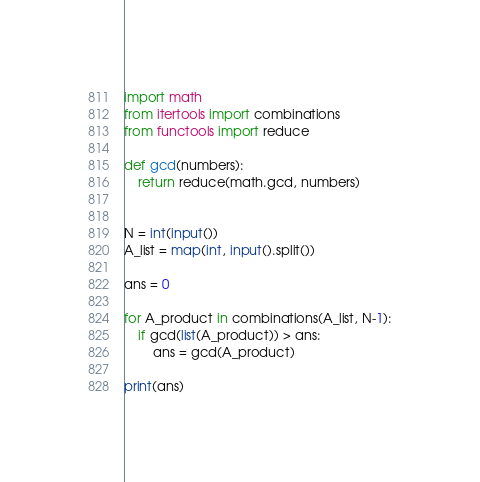<code> <loc_0><loc_0><loc_500><loc_500><_Python_>import math
from itertools import combinations
from functools import reduce

def gcd(numbers):
    return reduce(math.gcd, numbers)


N = int(input())
A_list = map(int, input().split())

ans = 0

for A_product in combinations(A_list, N-1):
    if gcd(list(A_product)) > ans:
        ans = gcd(A_product)

print(ans)</code> 